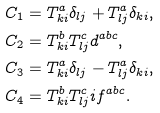<formula> <loc_0><loc_0><loc_500><loc_500>C _ { 1 } & = T _ { k i } ^ { a } \delta _ { l j } + T _ { l j } ^ { a } \delta _ { k i } , \\ C _ { 2 } & = T _ { k i } ^ { b } T _ { l j } ^ { c } d ^ { a b c } , \\ C _ { 3 } & = T _ { k i } ^ { a } \delta _ { l j } - T _ { l j } ^ { a } \delta _ { k i } , \\ C _ { 4 } & = T _ { k i } ^ { b } T _ { l j } ^ { c } i f ^ { a b c } .</formula> 